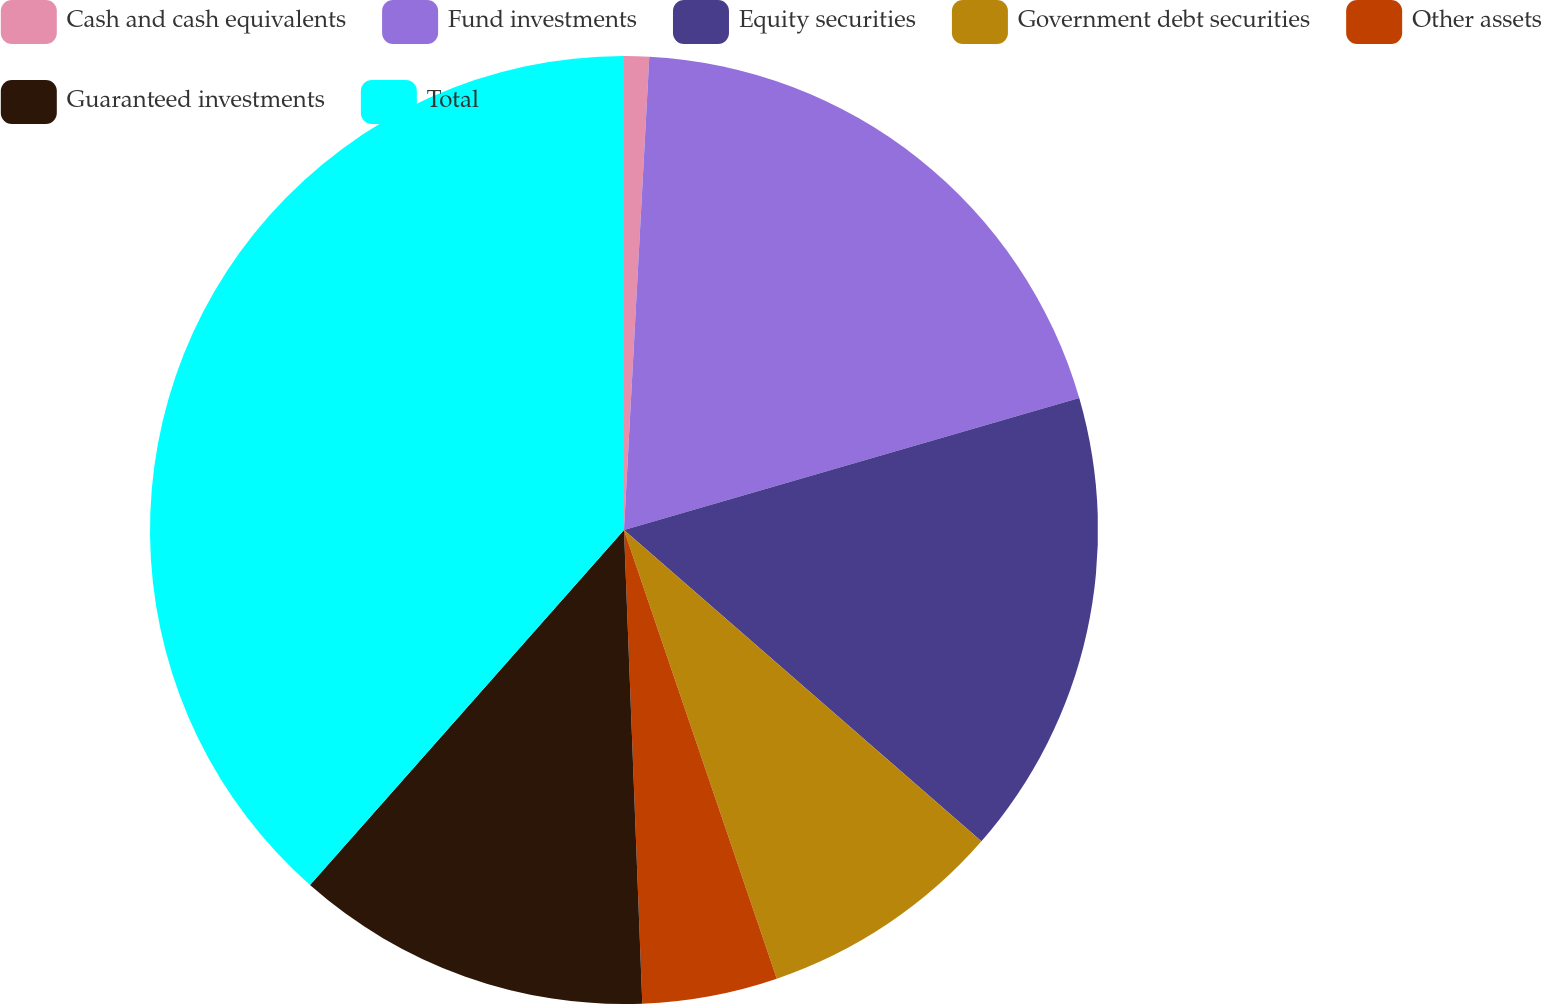Convert chart. <chart><loc_0><loc_0><loc_500><loc_500><pie_chart><fcel>Cash and cash equivalents<fcel>Fund investments<fcel>Equity securities<fcel>Government debt securities<fcel>Other assets<fcel>Guaranteed investments<fcel>Total<nl><fcel>0.85%<fcel>19.66%<fcel>15.9%<fcel>8.37%<fcel>4.61%<fcel>12.14%<fcel>38.48%<nl></chart> 